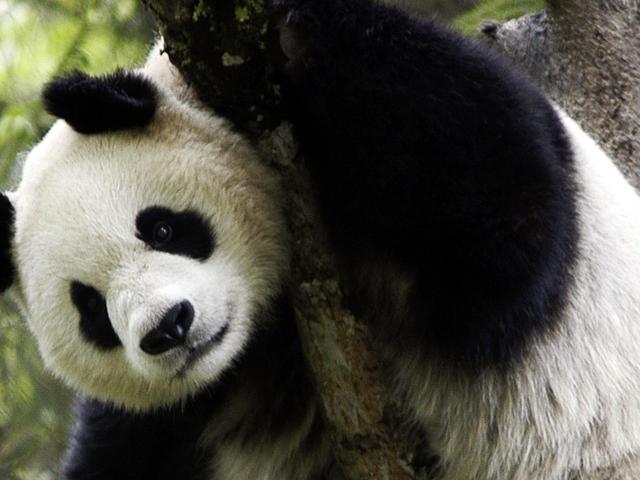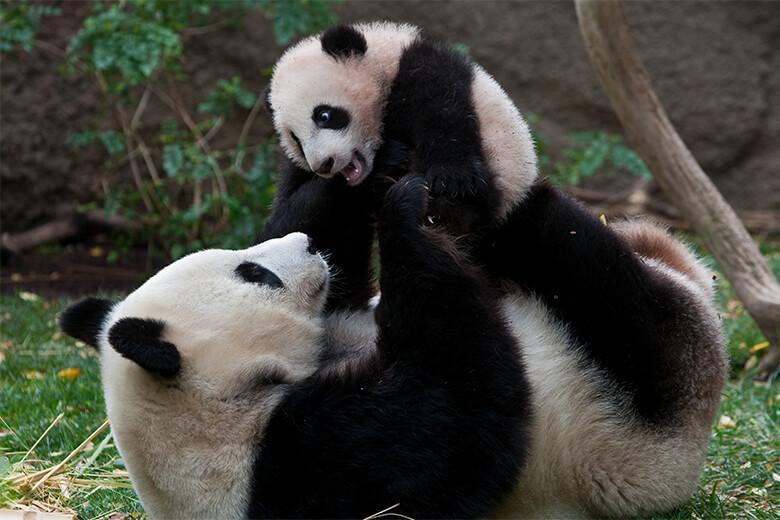The first image is the image on the left, the second image is the image on the right. Given the left and right images, does the statement "An image shows an adult panda on its back, playing with a young panda on top." hold true? Answer yes or no. Yes. 